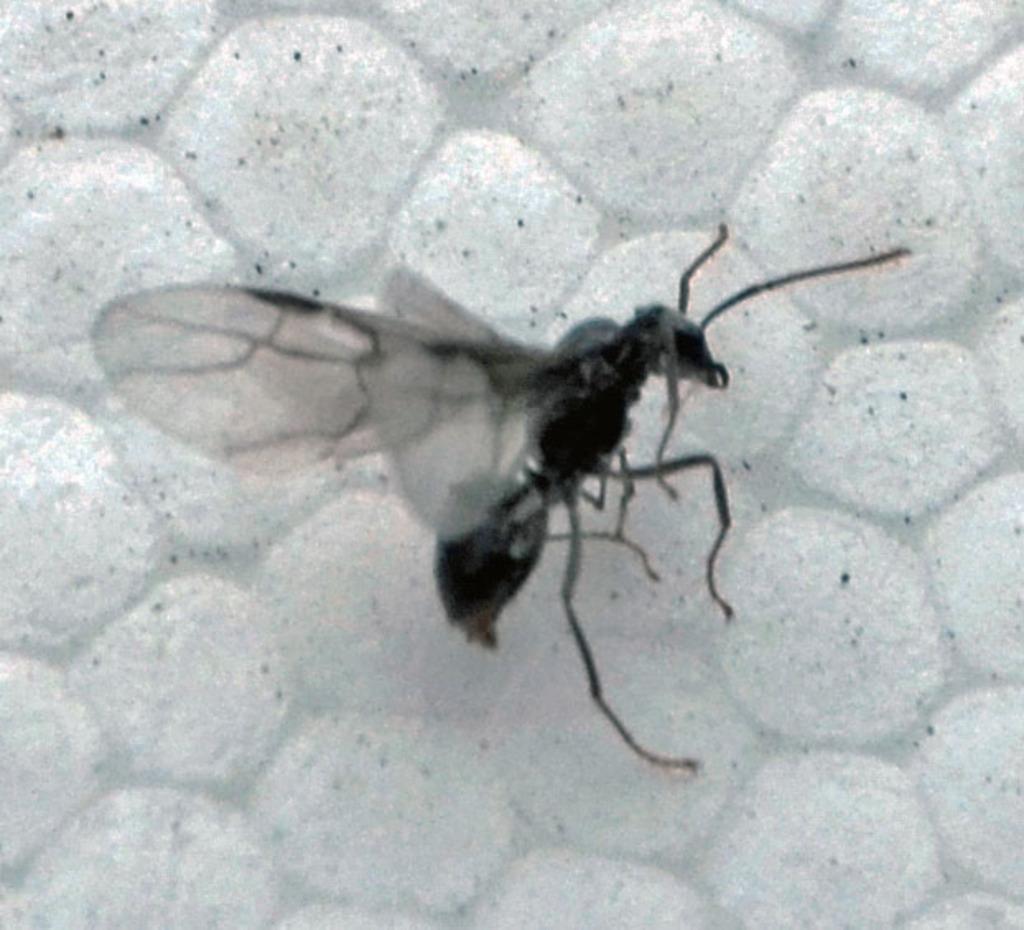Describe this image in one or two sentences. This is a black and white image. Here I can see an insect which is in black color on a white color object. 